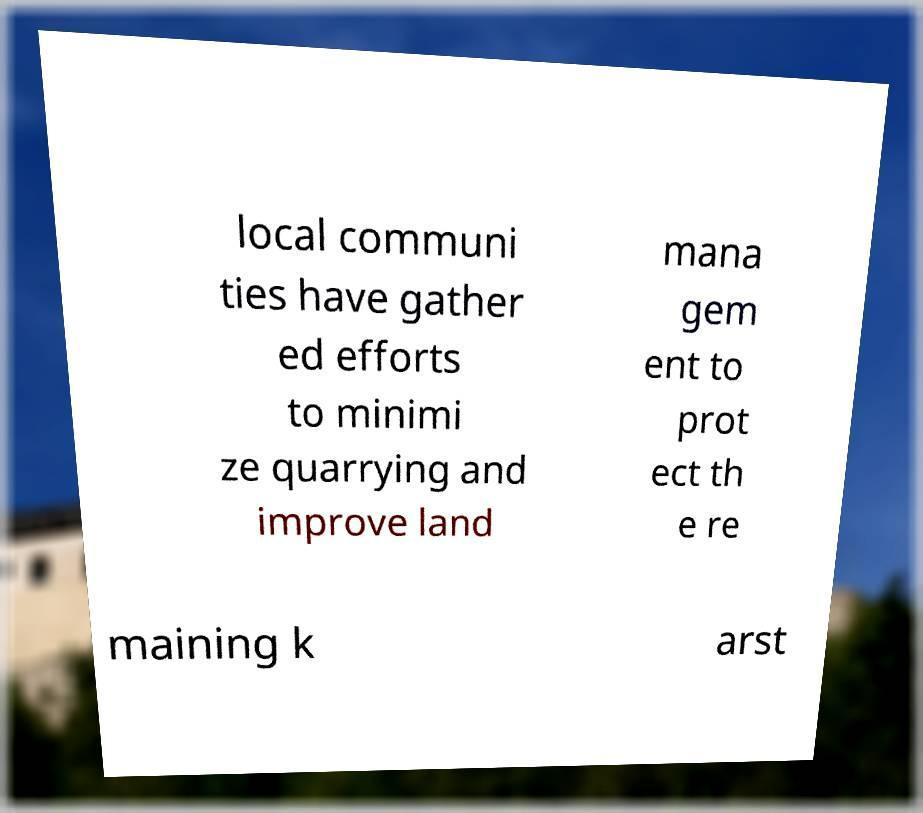Could you extract and type out the text from this image? local communi ties have gather ed efforts to minimi ze quarrying and improve land mana gem ent to prot ect th e re maining k arst 